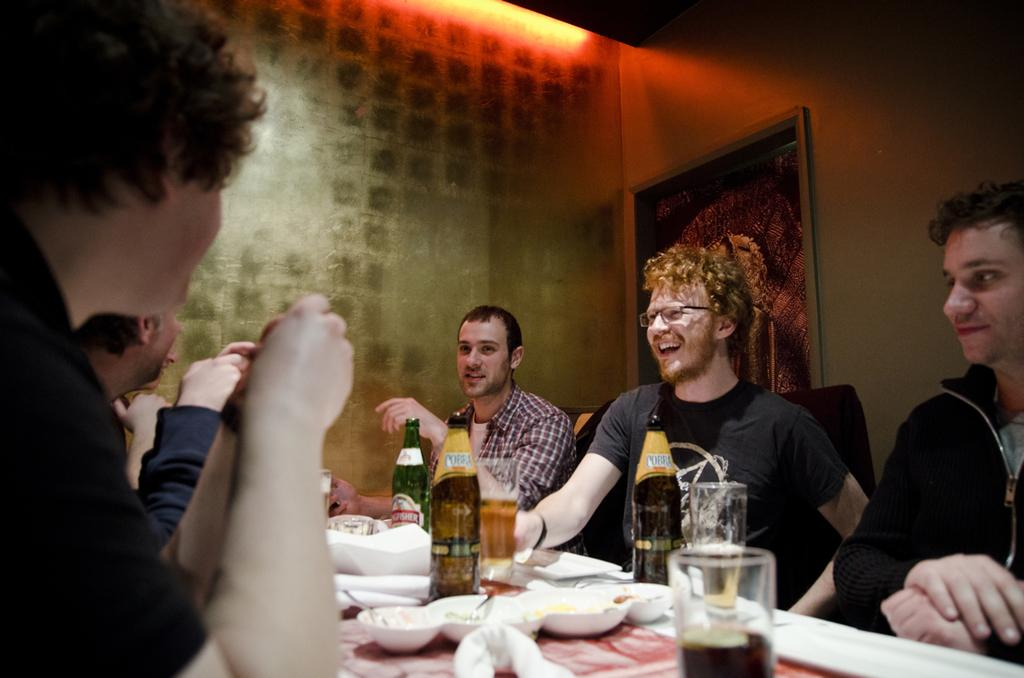How many people are in the image? There are many people in the image. What are the people doing in the image? The people are sitting at a table. What objects can be seen on the table? There are glass bottles and plates on the table. What can be seen in the background of the image? There is a painting and a red light in the background of the image. What type of cake is being lifted by the people in the image? There is no cake present in the image, and no one is lifting anything. 